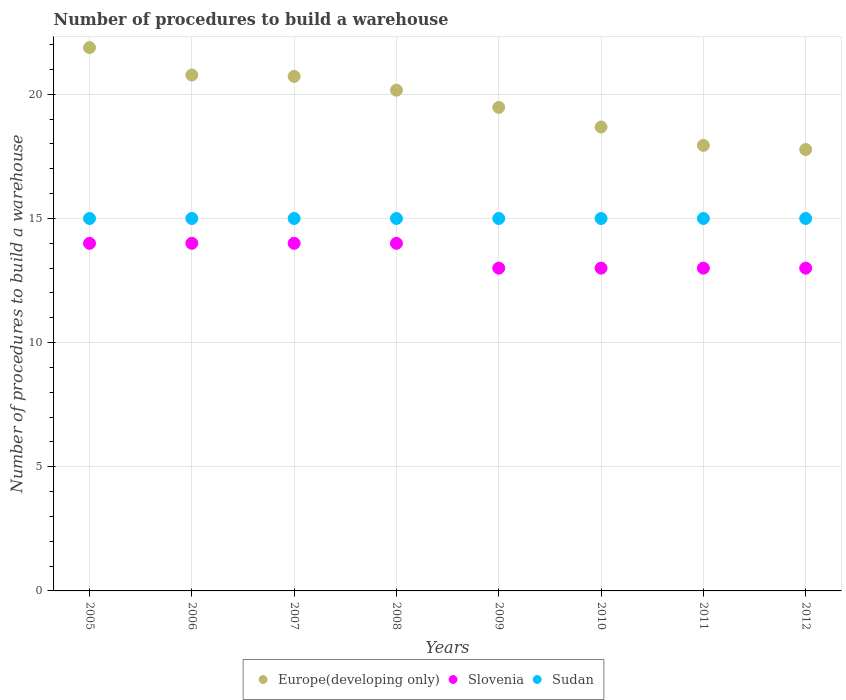How many different coloured dotlines are there?
Your answer should be compact. 3. Is the number of dotlines equal to the number of legend labels?
Provide a succinct answer. Yes. What is the number of procedures to build a warehouse in in Slovenia in 2009?
Your answer should be very brief. 13. Across all years, what is the maximum number of procedures to build a warehouse in in Europe(developing only)?
Provide a succinct answer. 21.88. Across all years, what is the minimum number of procedures to build a warehouse in in Sudan?
Keep it short and to the point. 15. What is the total number of procedures to build a warehouse in in Slovenia in the graph?
Your response must be concise. 108. What is the difference between the number of procedures to build a warehouse in in Slovenia in 2005 and that in 2009?
Your answer should be very brief. 1. What is the difference between the number of procedures to build a warehouse in in Sudan in 2009 and the number of procedures to build a warehouse in in Slovenia in 2008?
Offer a terse response. 1. In the year 2012, what is the difference between the number of procedures to build a warehouse in in Slovenia and number of procedures to build a warehouse in in Sudan?
Ensure brevity in your answer.  -2. In how many years, is the number of procedures to build a warehouse in in Sudan greater than 7?
Make the answer very short. 8. What is the ratio of the number of procedures to build a warehouse in in Sudan in 2006 to that in 2007?
Your answer should be very brief. 1. Is the number of procedures to build a warehouse in in Europe(developing only) in 2007 less than that in 2010?
Give a very brief answer. No. What is the difference between the highest and the lowest number of procedures to build a warehouse in in Sudan?
Provide a short and direct response. 0. In how many years, is the number of procedures to build a warehouse in in Sudan greater than the average number of procedures to build a warehouse in in Sudan taken over all years?
Offer a terse response. 0. Is the sum of the number of procedures to build a warehouse in in Slovenia in 2009 and 2010 greater than the maximum number of procedures to build a warehouse in in Europe(developing only) across all years?
Make the answer very short. Yes. Is it the case that in every year, the sum of the number of procedures to build a warehouse in in Sudan and number of procedures to build a warehouse in in Europe(developing only)  is greater than the number of procedures to build a warehouse in in Slovenia?
Provide a short and direct response. Yes. Is the number of procedures to build a warehouse in in Slovenia strictly less than the number of procedures to build a warehouse in in Sudan over the years?
Offer a very short reply. Yes. How many years are there in the graph?
Offer a terse response. 8. What is the difference between two consecutive major ticks on the Y-axis?
Your response must be concise. 5. Are the values on the major ticks of Y-axis written in scientific E-notation?
Your response must be concise. No. Does the graph contain grids?
Your response must be concise. Yes. Where does the legend appear in the graph?
Your answer should be compact. Bottom center. How are the legend labels stacked?
Ensure brevity in your answer.  Horizontal. What is the title of the graph?
Your answer should be very brief. Number of procedures to build a warehouse. Does "St. Vincent and the Grenadines" appear as one of the legend labels in the graph?
Your answer should be compact. No. What is the label or title of the X-axis?
Give a very brief answer. Years. What is the label or title of the Y-axis?
Provide a short and direct response. Number of procedures to build a warehouse. What is the Number of procedures to build a warehouse of Europe(developing only) in 2005?
Your response must be concise. 21.88. What is the Number of procedures to build a warehouse in Sudan in 2005?
Provide a succinct answer. 15. What is the Number of procedures to build a warehouse in Europe(developing only) in 2006?
Your answer should be compact. 20.78. What is the Number of procedures to build a warehouse in Europe(developing only) in 2007?
Keep it short and to the point. 20.72. What is the Number of procedures to build a warehouse in Sudan in 2007?
Keep it short and to the point. 15. What is the Number of procedures to build a warehouse of Europe(developing only) in 2008?
Provide a short and direct response. 20.17. What is the Number of procedures to build a warehouse in Europe(developing only) in 2009?
Make the answer very short. 19.47. What is the Number of procedures to build a warehouse of Sudan in 2009?
Offer a very short reply. 15. What is the Number of procedures to build a warehouse in Europe(developing only) in 2010?
Ensure brevity in your answer.  18.68. What is the Number of procedures to build a warehouse of Sudan in 2010?
Your answer should be very brief. 15. What is the Number of procedures to build a warehouse in Europe(developing only) in 2011?
Make the answer very short. 17.94. What is the Number of procedures to build a warehouse in Sudan in 2011?
Your response must be concise. 15. What is the Number of procedures to build a warehouse in Europe(developing only) in 2012?
Keep it short and to the point. 17.78. What is the Number of procedures to build a warehouse of Slovenia in 2012?
Provide a succinct answer. 13. Across all years, what is the maximum Number of procedures to build a warehouse of Europe(developing only)?
Offer a terse response. 21.88. Across all years, what is the maximum Number of procedures to build a warehouse of Sudan?
Your response must be concise. 15. Across all years, what is the minimum Number of procedures to build a warehouse in Europe(developing only)?
Your answer should be compact. 17.78. Across all years, what is the minimum Number of procedures to build a warehouse in Slovenia?
Make the answer very short. 13. What is the total Number of procedures to build a warehouse of Europe(developing only) in the graph?
Ensure brevity in your answer.  157.43. What is the total Number of procedures to build a warehouse of Slovenia in the graph?
Your answer should be very brief. 108. What is the total Number of procedures to build a warehouse in Sudan in the graph?
Provide a succinct answer. 120. What is the difference between the Number of procedures to build a warehouse of Europe(developing only) in 2005 and that in 2006?
Make the answer very short. 1.1. What is the difference between the Number of procedures to build a warehouse in Sudan in 2005 and that in 2006?
Your answer should be compact. 0. What is the difference between the Number of procedures to build a warehouse in Europe(developing only) in 2005 and that in 2007?
Keep it short and to the point. 1.16. What is the difference between the Number of procedures to build a warehouse in Slovenia in 2005 and that in 2007?
Your answer should be very brief. 0. What is the difference between the Number of procedures to build a warehouse in Europe(developing only) in 2005 and that in 2008?
Provide a succinct answer. 1.72. What is the difference between the Number of procedures to build a warehouse in Europe(developing only) in 2005 and that in 2009?
Offer a very short reply. 2.41. What is the difference between the Number of procedures to build a warehouse of Slovenia in 2005 and that in 2009?
Your response must be concise. 1. What is the difference between the Number of procedures to build a warehouse in Sudan in 2005 and that in 2009?
Your answer should be compact. 0. What is the difference between the Number of procedures to build a warehouse of Europe(developing only) in 2005 and that in 2010?
Make the answer very short. 3.2. What is the difference between the Number of procedures to build a warehouse of Sudan in 2005 and that in 2010?
Keep it short and to the point. 0. What is the difference between the Number of procedures to build a warehouse in Europe(developing only) in 2005 and that in 2011?
Offer a terse response. 3.94. What is the difference between the Number of procedures to build a warehouse of Slovenia in 2005 and that in 2011?
Offer a very short reply. 1. What is the difference between the Number of procedures to build a warehouse in Europe(developing only) in 2005 and that in 2012?
Your answer should be compact. 4.1. What is the difference between the Number of procedures to build a warehouse of Sudan in 2005 and that in 2012?
Provide a succinct answer. 0. What is the difference between the Number of procedures to build a warehouse in Europe(developing only) in 2006 and that in 2007?
Your answer should be very brief. 0.06. What is the difference between the Number of procedures to build a warehouse of Slovenia in 2006 and that in 2007?
Your response must be concise. 0. What is the difference between the Number of procedures to build a warehouse in Europe(developing only) in 2006 and that in 2008?
Offer a terse response. 0.61. What is the difference between the Number of procedures to build a warehouse of Slovenia in 2006 and that in 2008?
Your answer should be compact. 0. What is the difference between the Number of procedures to build a warehouse of Europe(developing only) in 2006 and that in 2009?
Your answer should be compact. 1.3. What is the difference between the Number of procedures to build a warehouse in Slovenia in 2006 and that in 2009?
Your answer should be compact. 1. What is the difference between the Number of procedures to build a warehouse of Europe(developing only) in 2006 and that in 2010?
Make the answer very short. 2.09. What is the difference between the Number of procedures to build a warehouse in Sudan in 2006 and that in 2010?
Your response must be concise. 0. What is the difference between the Number of procedures to build a warehouse of Europe(developing only) in 2006 and that in 2011?
Provide a short and direct response. 2.83. What is the difference between the Number of procedures to build a warehouse in Sudan in 2006 and that in 2011?
Make the answer very short. 0. What is the difference between the Number of procedures to build a warehouse of Europe(developing only) in 2006 and that in 2012?
Offer a terse response. 3. What is the difference between the Number of procedures to build a warehouse of Slovenia in 2006 and that in 2012?
Give a very brief answer. 1. What is the difference between the Number of procedures to build a warehouse in Sudan in 2006 and that in 2012?
Give a very brief answer. 0. What is the difference between the Number of procedures to build a warehouse in Europe(developing only) in 2007 and that in 2008?
Ensure brevity in your answer.  0.56. What is the difference between the Number of procedures to build a warehouse of Sudan in 2007 and that in 2008?
Keep it short and to the point. 0. What is the difference between the Number of procedures to build a warehouse of Europe(developing only) in 2007 and that in 2009?
Give a very brief answer. 1.25. What is the difference between the Number of procedures to build a warehouse of Sudan in 2007 and that in 2009?
Provide a short and direct response. 0. What is the difference between the Number of procedures to build a warehouse in Europe(developing only) in 2007 and that in 2010?
Offer a terse response. 2.04. What is the difference between the Number of procedures to build a warehouse of Europe(developing only) in 2007 and that in 2011?
Offer a very short reply. 2.78. What is the difference between the Number of procedures to build a warehouse in Slovenia in 2007 and that in 2011?
Provide a short and direct response. 1. What is the difference between the Number of procedures to build a warehouse of Europe(developing only) in 2007 and that in 2012?
Your answer should be very brief. 2.94. What is the difference between the Number of procedures to build a warehouse of Europe(developing only) in 2008 and that in 2009?
Your answer should be very brief. 0.69. What is the difference between the Number of procedures to build a warehouse of Sudan in 2008 and that in 2009?
Provide a short and direct response. 0. What is the difference between the Number of procedures to build a warehouse of Europe(developing only) in 2008 and that in 2010?
Your answer should be compact. 1.48. What is the difference between the Number of procedures to build a warehouse of Sudan in 2008 and that in 2010?
Keep it short and to the point. 0. What is the difference between the Number of procedures to build a warehouse in Europe(developing only) in 2008 and that in 2011?
Ensure brevity in your answer.  2.22. What is the difference between the Number of procedures to build a warehouse in Slovenia in 2008 and that in 2011?
Your answer should be compact. 1. What is the difference between the Number of procedures to build a warehouse in Sudan in 2008 and that in 2011?
Your answer should be compact. 0. What is the difference between the Number of procedures to build a warehouse in Europe(developing only) in 2008 and that in 2012?
Your answer should be very brief. 2.39. What is the difference between the Number of procedures to build a warehouse of Europe(developing only) in 2009 and that in 2010?
Offer a very short reply. 0.79. What is the difference between the Number of procedures to build a warehouse of Slovenia in 2009 and that in 2010?
Provide a succinct answer. 0. What is the difference between the Number of procedures to build a warehouse of Europe(developing only) in 2009 and that in 2011?
Provide a short and direct response. 1.53. What is the difference between the Number of procedures to build a warehouse of Europe(developing only) in 2009 and that in 2012?
Give a very brief answer. 1.7. What is the difference between the Number of procedures to build a warehouse in Slovenia in 2009 and that in 2012?
Keep it short and to the point. 0. What is the difference between the Number of procedures to build a warehouse of Europe(developing only) in 2010 and that in 2011?
Your answer should be very brief. 0.74. What is the difference between the Number of procedures to build a warehouse in Slovenia in 2010 and that in 2011?
Offer a terse response. 0. What is the difference between the Number of procedures to build a warehouse in Europe(developing only) in 2010 and that in 2012?
Offer a very short reply. 0.91. What is the difference between the Number of procedures to build a warehouse of Slovenia in 2010 and that in 2012?
Your answer should be compact. 0. What is the difference between the Number of procedures to build a warehouse of Sudan in 2010 and that in 2012?
Your answer should be compact. 0. What is the difference between the Number of procedures to build a warehouse of Sudan in 2011 and that in 2012?
Your response must be concise. 0. What is the difference between the Number of procedures to build a warehouse of Europe(developing only) in 2005 and the Number of procedures to build a warehouse of Slovenia in 2006?
Your answer should be very brief. 7.88. What is the difference between the Number of procedures to build a warehouse in Europe(developing only) in 2005 and the Number of procedures to build a warehouse in Sudan in 2006?
Your answer should be compact. 6.88. What is the difference between the Number of procedures to build a warehouse in Europe(developing only) in 2005 and the Number of procedures to build a warehouse in Slovenia in 2007?
Provide a short and direct response. 7.88. What is the difference between the Number of procedures to build a warehouse of Europe(developing only) in 2005 and the Number of procedures to build a warehouse of Sudan in 2007?
Offer a very short reply. 6.88. What is the difference between the Number of procedures to build a warehouse in Slovenia in 2005 and the Number of procedures to build a warehouse in Sudan in 2007?
Make the answer very short. -1. What is the difference between the Number of procedures to build a warehouse of Europe(developing only) in 2005 and the Number of procedures to build a warehouse of Slovenia in 2008?
Provide a succinct answer. 7.88. What is the difference between the Number of procedures to build a warehouse in Europe(developing only) in 2005 and the Number of procedures to build a warehouse in Sudan in 2008?
Ensure brevity in your answer.  6.88. What is the difference between the Number of procedures to build a warehouse in Slovenia in 2005 and the Number of procedures to build a warehouse in Sudan in 2008?
Provide a short and direct response. -1. What is the difference between the Number of procedures to build a warehouse in Europe(developing only) in 2005 and the Number of procedures to build a warehouse in Slovenia in 2009?
Offer a very short reply. 8.88. What is the difference between the Number of procedures to build a warehouse in Europe(developing only) in 2005 and the Number of procedures to build a warehouse in Sudan in 2009?
Ensure brevity in your answer.  6.88. What is the difference between the Number of procedures to build a warehouse in Europe(developing only) in 2005 and the Number of procedures to build a warehouse in Slovenia in 2010?
Provide a short and direct response. 8.88. What is the difference between the Number of procedures to build a warehouse of Europe(developing only) in 2005 and the Number of procedures to build a warehouse of Sudan in 2010?
Your answer should be compact. 6.88. What is the difference between the Number of procedures to build a warehouse of Europe(developing only) in 2005 and the Number of procedures to build a warehouse of Slovenia in 2011?
Provide a succinct answer. 8.88. What is the difference between the Number of procedures to build a warehouse in Europe(developing only) in 2005 and the Number of procedures to build a warehouse in Sudan in 2011?
Ensure brevity in your answer.  6.88. What is the difference between the Number of procedures to build a warehouse of Europe(developing only) in 2005 and the Number of procedures to build a warehouse of Slovenia in 2012?
Your response must be concise. 8.88. What is the difference between the Number of procedures to build a warehouse in Europe(developing only) in 2005 and the Number of procedures to build a warehouse in Sudan in 2012?
Your response must be concise. 6.88. What is the difference between the Number of procedures to build a warehouse in Europe(developing only) in 2006 and the Number of procedures to build a warehouse in Slovenia in 2007?
Your answer should be compact. 6.78. What is the difference between the Number of procedures to build a warehouse of Europe(developing only) in 2006 and the Number of procedures to build a warehouse of Sudan in 2007?
Provide a succinct answer. 5.78. What is the difference between the Number of procedures to build a warehouse of Slovenia in 2006 and the Number of procedures to build a warehouse of Sudan in 2007?
Your response must be concise. -1. What is the difference between the Number of procedures to build a warehouse of Europe(developing only) in 2006 and the Number of procedures to build a warehouse of Slovenia in 2008?
Your answer should be compact. 6.78. What is the difference between the Number of procedures to build a warehouse of Europe(developing only) in 2006 and the Number of procedures to build a warehouse of Sudan in 2008?
Give a very brief answer. 5.78. What is the difference between the Number of procedures to build a warehouse of Europe(developing only) in 2006 and the Number of procedures to build a warehouse of Slovenia in 2009?
Your answer should be very brief. 7.78. What is the difference between the Number of procedures to build a warehouse of Europe(developing only) in 2006 and the Number of procedures to build a warehouse of Sudan in 2009?
Make the answer very short. 5.78. What is the difference between the Number of procedures to build a warehouse in Slovenia in 2006 and the Number of procedures to build a warehouse in Sudan in 2009?
Provide a short and direct response. -1. What is the difference between the Number of procedures to build a warehouse in Europe(developing only) in 2006 and the Number of procedures to build a warehouse in Slovenia in 2010?
Keep it short and to the point. 7.78. What is the difference between the Number of procedures to build a warehouse of Europe(developing only) in 2006 and the Number of procedures to build a warehouse of Sudan in 2010?
Keep it short and to the point. 5.78. What is the difference between the Number of procedures to build a warehouse in Europe(developing only) in 2006 and the Number of procedures to build a warehouse in Slovenia in 2011?
Your response must be concise. 7.78. What is the difference between the Number of procedures to build a warehouse in Europe(developing only) in 2006 and the Number of procedures to build a warehouse in Sudan in 2011?
Ensure brevity in your answer.  5.78. What is the difference between the Number of procedures to build a warehouse of Europe(developing only) in 2006 and the Number of procedures to build a warehouse of Slovenia in 2012?
Offer a terse response. 7.78. What is the difference between the Number of procedures to build a warehouse of Europe(developing only) in 2006 and the Number of procedures to build a warehouse of Sudan in 2012?
Ensure brevity in your answer.  5.78. What is the difference between the Number of procedures to build a warehouse in Slovenia in 2006 and the Number of procedures to build a warehouse in Sudan in 2012?
Your answer should be compact. -1. What is the difference between the Number of procedures to build a warehouse in Europe(developing only) in 2007 and the Number of procedures to build a warehouse in Slovenia in 2008?
Give a very brief answer. 6.72. What is the difference between the Number of procedures to build a warehouse of Europe(developing only) in 2007 and the Number of procedures to build a warehouse of Sudan in 2008?
Keep it short and to the point. 5.72. What is the difference between the Number of procedures to build a warehouse in Slovenia in 2007 and the Number of procedures to build a warehouse in Sudan in 2008?
Make the answer very short. -1. What is the difference between the Number of procedures to build a warehouse of Europe(developing only) in 2007 and the Number of procedures to build a warehouse of Slovenia in 2009?
Your response must be concise. 7.72. What is the difference between the Number of procedures to build a warehouse of Europe(developing only) in 2007 and the Number of procedures to build a warehouse of Sudan in 2009?
Provide a short and direct response. 5.72. What is the difference between the Number of procedures to build a warehouse of Slovenia in 2007 and the Number of procedures to build a warehouse of Sudan in 2009?
Your response must be concise. -1. What is the difference between the Number of procedures to build a warehouse in Europe(developing only) in 2007 and the Number of procedures to build a warehouse in Slovenia in 2010?
Make the answer very short. 7.72. What is the difference between the Number of procedures to build a warehouse of Europe(developing only) in 2007 and the Number of procedures to build a warehouse of Sudan in 2010?
Provide a short and direct response. 5.72. What is the difference between the Number of procedures to build a warehouse in Europe(developing only) in 2007 and the Number of procedures to build a warehouse in Slovenia in 2011?
Provide a succinct answer. 7.72. What is the difference between the Number of procedures to build a warehouse of Europe(developing only) in 2007 and the Number of procedures to build a warehouse of Sudan in 2011?
Your answer should be very brief. 5.72. What is the difference between the Number of procedures to build a warehouse in Slovenia in 2007 and the Number of procedures to build a warehouse in Sudan in 2011?
Offer a terse response. -1. What is the difference between the Number of procedures to build a warehouse of Europe(developing only) in 2007 and the Number of procedures to build a warehouse of Slovenia in 2012?
Give a very brief answer. 7.72. What is the difference between the Number of procedures to build a warehouse in Europe(developing only) in 2007 and the Number of procedures to build a warehouse in Sudan in 2012?
Your answer should be compact. 5.72. What is the difference between the Number of procedures to build a warehouse of Europe(developing only) in 2008 and the Number of procedures to build a warehouse of Slovenia in 2009?
Ensure brevity in your answer.  7.17. What is the difference between the Number of procedures to build a warehouse of Europe(developing only) in 2008 and the Number of procedures to build a warehouse of Sudan in 2009?
Provide a succinct answer. 5.17. What is the difference between the Number of procedures to build a warehouse of Slovenia in 2008 and the Number of procedures to build a warehouse of Sudan in 2009?
Give a very brief answer. -1. What is the difference between the Number of procedures to build a warehouse of Europe(developing only) in 2008 and the Number of procedures to build a warehouse of Slovenia in 2010?
Provide a short and direct response. 7.17. What is the difference between the Number of procedures to build a warehouse of Europe(developing only) in 2008 and the Number of procedures to build a warehouse of Sudan in 2010?
Make the answer very short. 5.17. What is the difference between the Number of procedures to build a warehouse in Europe(developing only) in 2008 and the Number of procedures to build a warehouse in Slovenia in 2011?
Make the answer very short. 7.17. What is the difference between the Number of procedures to build a warehouse in Europe(developing only) in 2008 and the Number of procedures to build a warehouse in Sudan in 2011?
Offer a terse response. 5.17. What is the difference between the Number of procedures to build a warehouse of Slovenia in 2008 and the Number of procedures to build a warehouse of Sudan in 2011?
Offer a terse response. -1. What is the difference between the Number of procedures to build a warehouse in Europe(developing only) in 2008 and the Number of procedures to build a warehouse in Slovenia in 2012?
Offer a terse response. 7.17. What is the difference between the Number of procedures to build a warehouse in Europe(developing only) in 2008 and the Number of procedures to build a warehouse in Sudan in 2012?
Your response must be concise. 5.17. What is the difference between the Number of procedures to build a warehouse in Slovenia in 2008 and the Number of procedures to build a warehouse in Sudan in 2012?
Offer a terse response. -1. What is the difference between the Number of procedures to build a warehouse in Europe(developing only) in 2009 and the Number of procedures to build a warehouse in Slovenia in 2010?
Make the answer very short. 6.47. What is the difference between the Number of procedures to build a warehouse of Europe(developing only) in 2009 and the Number of procedures to build a warehouse of Sudan in 2010?
Provide a short and direct response. 4.47. What is the difference between the Number of procedures to build a warehouse in Europe(developing only) in 2009 and the Number of procedures to build a warehouse in Slovenia in 2011?
Give a very brief answer. 6.47. What is the difference between the Number of procedures to build a warehouse in Europe(developing only) in 2009 and the Number of procedures to build a warehouse in Sudan in 2011?
Keep it short and to the point. 4.47. What is the difference between the Number of procedures to build a warehouse of Slovenia in 2009 and the Number of procedures to build a warehouse of Sudan in 2011?
Give a very brief answer. -2. What is the difference between the Number of procedures to build a warehouse of Europe(developing only) in 2009 and the Number of procedures to build a warehouse of Slovenia in 2012?
Ensure brevity in your answer.  6.47. What is the difference between the Number of procedures to build a warehouse in Europe(developing only) in 2009 and the Number of procedures to build a warehouse in Sudan in 2012?
Provide a succinct answer. 4.47. What is the difference between the Number of procedures to build a warehouse of Slovenia in 2009 and the Number of procedures to build a warehouse of Sudan in 2012?
Provide a short and direct response. -2. What is the difference between the Number of procedures to build a warehouse of Europe(developing only) in 2010 and the Number of procedures to build a warehouse of Slovenia in 2011?
Keep it short and to the point. 5.68. What is the difference between the Number of procedures to build a warehouse in Europe(developing only) in 2010 and the Number of procedures to build a warehouse in Sudan in 2011?
Ensure brevity in your answer.  3.68. What is the difference between the Number of procedures to build a warehouse of Slovenia in 2010 and the Number of procedures to build a warehouse of Sudan in 2011?
Keep it short and to the point. -2. What is the difference between the Number of procedures to build a warehouse in Europe(developing only) in 2010 and the Number of procedures to build a warehouse in Slovenia in 2012?
Your answer should be very brief. 5.68. What is the difference between the Number of procedures to build a warehouse of Europe(developing only) in 2010 and the Number of procedures to build a warehouse of Sudan in 2012?
Ensure brevity in your answer.  3.68. What is the difference between the Number of procedures to build a warehouse of Europe(developing only) in 2011 and the Number of procedures to build a warehouse of Slovenia in 2012?
Your answer should be very brief. 4.94. What is the difference between the Number of procedures to build a warehouse of Europe(developing only) in 2011 and the Number of procedures to build a warehouse of Sudan in 2012?
Provide a short and direct response. 2.94. What is the difference between the Number of procedures to build a warehouse of Slovenia in 2011 and the Number of procedures to build a warehouse of Sudan in 2012?
Ensure brevity in your answer.  -2. What is the average Number of procedures to build a warehouse in Europe(developing only) per year?
Ensure brevity in your answer.  19.68. What is the average Number of procedures to build a warehouse of Slovenia per year?
Provide a succinct answer. 13.5. What is the average Number of procedures to build a warehouse in Sudan per year?
Provide a short and direct response. 15. In the year 2005, what is the difference between the Number of procedures to build a warehouse of Europe(developing only) and Number of procedures to build a warehouse of Slovenia?
Keep it short and to the point. 7.88. In the year 2005, what is the difference between the Number of procedures to build a warehouse of Europe(developing only) and Number of procedures to build a warehouse of Sudan?
Offer a very short reply. 6.88. In the year 2005, what is the difference between the Number of procedures to build a warehouse of Slovenia and Number of procedures to build a warehouse of Sudan?
Keep it short and to the point. -1. In the year 2006, what is the difference between the Number of procedures to build a warehouse of Europe(developing only) and Number of procedures to build a warehouse of Slovenia?
Make the answer very short. 6.78. In the year 2006, what is the difference between the Number of procedures to build a warehouse in Europe(developing only) and Number of procedures to build a warehouse in Sudan?
Keep it short and to the point. 5.78. In the year 2006, what is the difference between the Number of procedures to build a warehouse in Slovenia and Number of procedures to build a warehouse in Sudan?
Keep it short and to the point. -1. In the year 2007, what is the difference between the Number of procedures to build a warehouse in Europe(developing only) and Number of procedures to build a warehouse in Slovenia?
Provide a short and direct response. 6.72. In the year 2007, what is the difference between the Number of procedures to build a warehouse in Europe(developing only) and Number of procedures to build a warehouse in Sudan?
Ensure brevity in your answer.  5.72. In the year 2007, what is the difference between the Number of procedures to build a warehouse of Slovenia and Number of procedures to build a warehouse of Sudan?
Ensure brevity in your answer.  -1. In the year 2008, what is the difference between the Number of procedures to build a warehouse in Europe(developing only) and Number of procedures to build a warehouse in Slovenia?
Provide a succinct answer. 6.17. In the year 2008, what is the difference between the Number of procedures to build a warehouse of Europe(developing only) and Number of procedures to build a warehouse of Sudan?
Offer a terse response. 5.17. In the year 2008, what is the difference between the Number of procedures to build a warehouse in Slovenia and Number of procedures to build a warehouse in Sudan?
Offer a terse response. -1. In the year 2009, what is the difference between the Number of procedures to build a warehouse in Europe(developing only) and Number of procedures to build a warehouse in Slovenia?
Provide a succinct answer. 6.47. In the year 2009, what is the difference between the Number of procedures to build a warehouse of Europe(developing only) and Number of procedures to build a warehouse of Sudan?
Offer a terse response. 4.47. In the year 2010, what is the difference between the Number of procedures to build a warehouse of Europe(developing only) and Number of procedures to build a warehouse of Slovenia?
Ensure brevity in your answer.  5.68. In the year 2010, what is the difference between the Number of procedures to build a warehouse in Europe(developing only) and Number of procedures to build a warehouse in Sudan?
Give a very brief answer. 3.68. In the year 2011, what is the difference between the Number of procedures to build a warehouse of Europe(developing only) and Number of procedures to build a warehouse of Slovenia?
Your answer should be very brief. 4.94. In the year 2011, what is the difference between the Number of procedures to build a warehouse of Europe(developing only) and Number of procedures to build a warehouse of Sudan?
Provide a succinct answer. 2.94. In the year 2012, what is the difference between the Number of procedures to build a warehouse of Europe(developing only) and Number of procedures to build a warehouse of Slovenia?
Your response must be concise. 4.78. In the year 2012, what is the difference between the Number of procedures to build a warehouse of Europe(developing only) and Number of procedures to build a warehouse of Sudan?
Make the answer very short. 2.78. In the year 2012, what is the difference between the Number of procedures to build a warehouse in Slovenia and Number of procedures to build a warehouse in Sudan?
Provide a succinct answer. -2. What is the ratio of the Number of procedures to build a warehouse in Europe(developing only) in 2005 to that in 2006?
Provide a succinct answer. 1.05. What is the ratio of the Number of procedures to build a warehouse of Slovenia in 2005 to that in 2006?
Offer a very short reply. 1. What is the ratio of the Number of procedures to build a warehouse in Sudan in 2005 to that in 2006?
Your answer should be compact. 1. What is the ratio of the Number of procedures to build a warehouse of Europe(developing only) in 2005 to that in 2007?
Your response must be concise. 1.06. What is the ratio of the Number of procedures to build a warehouse of Slovenia in 2005 to that in 2007?
Offer a terse response. 1. What is the ratio of the Number of procedures to build a warehouse of Europe(developing only) in 2005 to that in 2008?
Provide a succinct answer. 1.09. What is the ratio of the Number of procedures to build a warehouse of Slovenia in 2005 to that in 2008?
Your answer should be compact. 1. What is the ratio of the Number of procedures to build a warehouse of Sudan in 2005 to that in 2008?
Your response must be concise. 1. What is the ratio of the Number of procedures to build a warehouse of Europe(developing only) in 2005 to that in 2009?
Offer a terse response. 1.12. What is the ratio of the Number of procedures to build a warehouse in Slovenia in 2005 to that in 2009?
Ensure brevity in your answer.  1.08. What is the ratio of the Number of procedures to build a warehouse in Sudan in 2005 to that in 2009?
Your answer should be compact. 1. What is the ratio of the Number of procedures to build a warehouse of Europe(developing only) in 2005 to that in 2010?
Your response must be concise. 1.17. What is the ratio of the Number of procedures to build a warehouse in Europe(developing only) in 2005 to that in 2011?
Make the answer very short. 1.22. What is the ratio of the Number of procedures to build a warehouse of Sudan in 2005 to that in 2011?
Keep it short and to the point. 1. What is the ratio of the Number of procedures to build a warehouse in Europe(developing only) in 2005 to that in 2012?
Make the answer very short. 1.23. What is the ratio of the Number of procedures to build a warehouse of Slovenia in 2005 to that in 2012?
Provide a short and direct response. 1.08. What is the ratio of the Number of procedures to build a warehouse in Sudan in 2005 to that in 2012?
Provide a short and direct response. 1. What is the ratio of the Number of procedures to build a warehouse of Europe(developing only) in 2006 to that in 2007?
Make the answer very short. 1. What is the ratio of the Number of procedures to build a warehouse of Sudan in 2006 to that in 2007?
Offer a very short reply. 1. What is the ratio of the Number of procedures to build a warehouse in Europe(developing only) in 2006 to that in 2008?
Your answer should be compact. 1.03. What is the ratio of the Number of procedures to build a warehouse of Europe(developing only) in 2006 to that in 2009?
Make the answer very short. 1.07. What is the ratio of the Number of procedures to build a warehouse in Slovenia in 2006 to that in 2009?
Keep it short and to the point. 1.08. What is the ratio of the Number of procedures to build a warehouse of Sudan in 2006 to that in 2009?
Offer a very short reply. 1. What is the ratio of the Number of procedures to build a warehouse of Europe(developing only) in 2006 to that in 2010?
Your response must be concise. 1.11. What is the ratio of the Number of procedures to build a warehouse in Slovenia in 2006 to that in 2010?
Ensure brevity in your answer.  1.08. What is the ratio of the Number of procedures to build a warehouse in Sudan in 2006 to that in 2010?
Provide a short and direct response. 1. What is the ratio of the Number of procedures to build a warehouse of Europe(developing only) in 2006 to that in 2011?
Ensure brevity in your answer.  1.16. What is the ratio of the Number of procedures to build a warehouse in Slovenia in 2006 to that in 2011?
Offer a terse response. 1.08. What is the ratio of the Number of procedures to build a warehouse in Europe(developing only) in 2006 to that in 2012?
Keep it short and to the point. 1.17. What is the ratio of the Number of procedures to build a warehouse in Slovenia in 2006 to that in 2012?
Ensure brevity in your answer.  1.08. What is the ratio of the Number of procedures to build a warehouse in Europe(developing only) in 2007 to that in 2008?
Give a very brief answer. 1.03. What is the ratio of the Number of procedures to build a warehouse of Slovenia in 2007 to that in 2008?
Your answer should be very brief. 1. What is the ratio of the Number of procedures to build a warehouse in Europe(developing only) in 2007 to that in 2009?
Keep it short and to the point. 1.06. What is the ratio of the Number of procedures to build a warehouse of Sudan in 2007 to that in 2009?
Give a very brief answer. 1. What is the ratio of the Number of procedures to build a warehouse in Europe(developing only) in 2007 to that in 2010?
Provide a succinct answer. 1.11. What is the ratio of the Number of procedures to build a warehouse in Sudan in 2007 to that in 2010?
Offer a terse response. 1. What is the ratio of the Number of procedures to build a warehouse in Europe(developing only) in 2007 to that in 2011?
Provide a short and direct response. 1.15. What is the ratio of the Number of procedures to build a warehouse in Europe(developing only) in 2007 to that in 2012?
Your response must be concise. 1.17. What is the ratio of the Number of procedures to build a warehouse in Slovenia in 2007 to that in 2012?
Offer a terse response. 1.08. What is the ratio of the Number of procedures to build a warehouse in Europe(developing only) in 2008 to that in 2009?
Provide a succinct answer. 1.04. What is the ratio of the Number of procedures to build a warehouse of Europe(developing only) in 2008 to that in 2010?
Give a very brief answer. 1.08. What is the ratio of the Number of procedures to build a warehouse in Europe(developing only) in 2008 to that in 2011?
Keep it short and to the point. 1.12. What is the ratio of the Number of procedures to build a warehouse in Slovenia in 2008 to that in 2011?
Keep it short and to the point. 1.08. What is the ratio of the Number of procedures to build a warehouse in Sudan in 2008 to that in 2011?
Ensure brevity in your answer.  1. What is the ratio of the Number of procedures to build a warehouse of Europe(developing only) in 2008 to that in 2012?
Make the answer very short. 1.13. What is the ratio of the Number of procedures to build a warehouse of Slovenia in 2008 to that in 2012?
Offer a very short reply. 1.08. What is the ratio of the Number of procedures to build a warehouse in Sudan in 2008 to that in 2012?
Offer a very short reply. 1. What is the ratio of the Number of procedures to build a warehouse of Europe(developing only) in 2009 to that in 2010?
Provide a succinct answer. 1.04. What is the ratio of the Number of procedures to build a warehouse of Slovenia in 2009 to that in 2010?
Keep it short and to the point. 1. What is the ratio of the Number of procedures to build a warehouse of Europe(developing only) in 2009 to that in 2011?
Ensure brevity in your answer.  1.09. What is the ratio of the Number of procedures to build a warehouse in Europe(developing only) in 2009 to that in 2012?
Your response must be concise. 1.1. What is the ratio of the Number of procedures to build a warehouse in Sudan in 2009 to that in 2012?
Your answer should be compact. 1. What is the ratio of the Number of procedures to build a warehouse in Europe(developing only) in 2010 to that in 2011?
Your answer should be very brief. 1.04. What is the ratio of the Number of procedures to build a warehouse in Slovenia in 2010 to that in 2011?
Your answer should be compact. 1. What is the ratio of the Number of procedures to build a warehouse in Sudan in 2010 to that in 2011?
Offer a very short reply. 1. What is the ratio of the Number of procedures to build a warehouse of Europe(developing only) in 2010 to that in 2012?
Offer a terse response. 1.05. What is the ratio of the Number of procedures to build a warehouse in Sudan in 2010 to that in 2012?
Offer a terse response. 1. What is the ratio of the Number of procedures to build a warehouse of Europe(developing only) in 2011 to that in 2012?
Give a very brief answer. 1.01. What is the ratio of the Number of procedures to build a warehouse of Slovenia in 2011 to that in 2012?
Offer a terse response. 1. What is the difference between the highest and the second highest Number of procedures to build a warehouse in Europe(developing only)?
Your answer should be compact. 1.1. What is the difference between the highest and the second highest Number of procedures to build a warehouse of Sudan?
Give a very brief answer. 0. What is the difference between the highest and the lowest Number of procedures to build a warehouse in Europe(developing only)?
Provide a short and direct response. 4.1. 